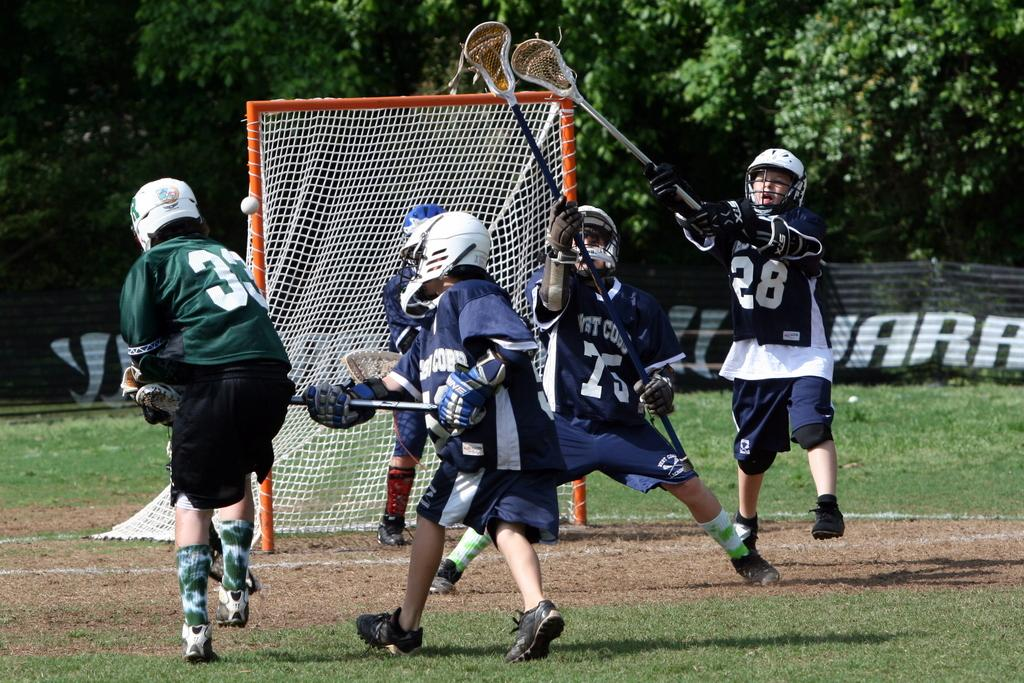What are the players in the image doing? The players in the image are holding sticks. What protective gear are the players wearing? The players are wearing helmets. What can be seen in the background of the image? There are trees visible in the image. What is the purpose of the net in the image? The net is likely used for separating the teams or scoring points in the game. What type of surface is the game being played on? There is a ground in the image, which suggests it is an outdoor playing field. What other object can be seen in the image? There is a board in the image, which might be used for keeping score or displaying game information. How many pizzas are being served to the players in the image? There is no indication of pizzas being served in the image; the players are holding sticks and wearing helmets. 